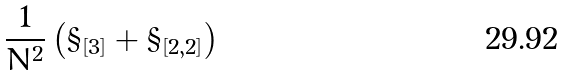<formula> <loc_0><loc_0><loc_500><loc_500>\frac { 1 } { N ^ { 2 } } \left ( \S _ { [ 3 ] } + \S _ { [ 2 , 2 ] } \right )</formula> 